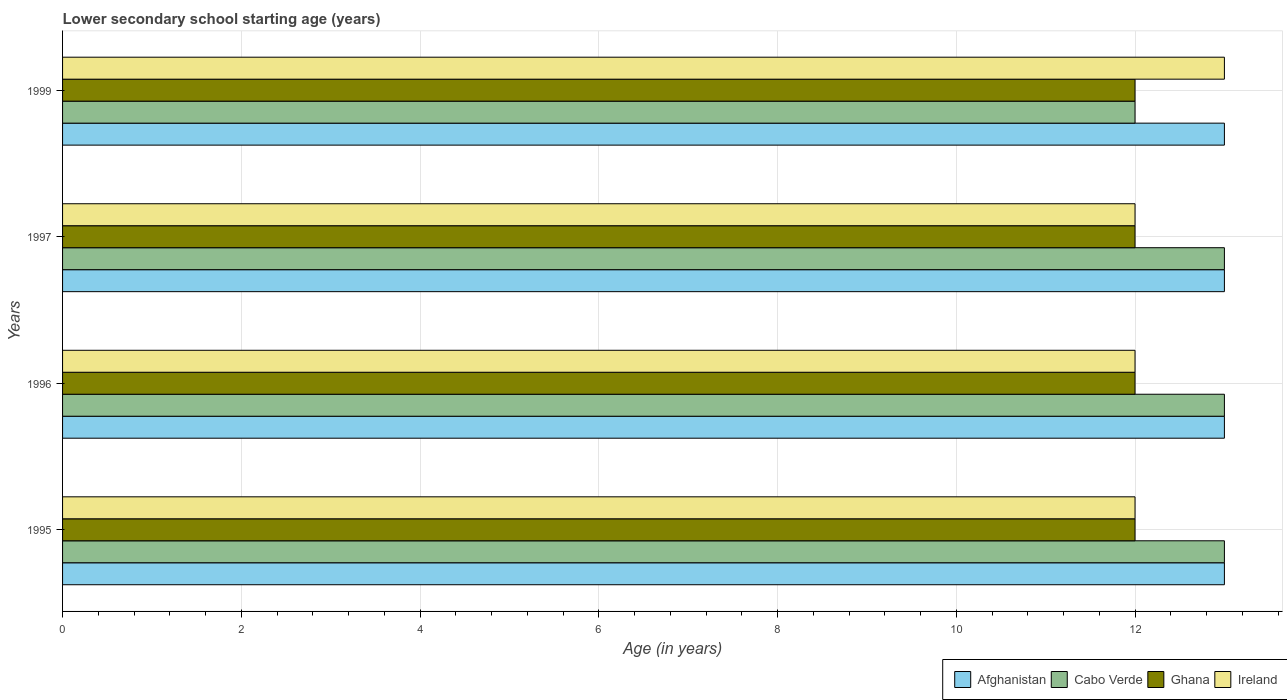How many groups of bars are there?
Your answer should be very brief. 4. Are the number of bars per tick equal to the number of legend labels?
Your response must be concise. Yes. Are the number of bars on each tick of the Y-axis equal?
Provide a succinct answer. Yes. How many bars are there on the 1st tick from the top?
Your response must be concise. 4. What is the label of the 4th group of bars from the top?
Make the answer very short. 1995. In how many cases, is the number of bars for a given year not equal to the number of legend labels?
Give a very brief answer. 0. What is the lower secondary school starting age of children in Ghana in 1997?
Your answer should be very brief. 12. Across all years, what is the maximum lower secondary school starting age of children in Cabo Verde?
Offer a very short reply. 13. Across all years, what is the minimum lower secondary school starting age of children in Ghana?
Provide a short and direct response. 12. In which year was the lower secondary school starting age of children in Cabo Verde maximum?
Provide a short and direct response. 1995. In which year was the lower secondary school starting age of children in Ireland minimum?
Keep it short and to the point. 1995. What is the difference between the lower secondary school starting age of children in Afghanistan in 1996 and that in 1999?
Give a very brief answer. 0. What is the average lower secondary school starting age of children in Cabo Verde per year?
Your answer should be compact. 12.75. In how many years, is the lower secondary school starting age of children in Cabo Verde greater than 1.2000000000000002 years?
Your answer should be very brief. 4. What is the ratio of the lower secondary school starting age of children in Ireland in 1995 to that in 1999?
Provide a succinct answer. 0.92. Is the lower secondary school starting age of children in Cabo Verde in 1997 less than that in 1999?
Offer a terse response. No. Is the difference between the lower secondary school starting age of children in Ireland in 1997 and 1999 greater than the difference between the lower secondary school starting age of children in Ghana in 1997 and 1999?
Provide a short and direct response. No. What is the difference between the highest and the second highest lower secondary school starting age of children in Ireland?
Ensure brevity in your answer.  1. What is the difference between the highest and the lowest lower secondary school starting age of children in Ghana?
Keep it short and to the point. 0. In how many years, is the lower secondary school starting age of children in Ireland greater than the average lower secondary school starting age of children in Ireland taken over all years?
Keep it short and to the point. 1. Is it the case that in every year, the sum of the lower secondary school starting age of children in Ghana and lower secondary school starting age of children in Cabo Verde is greater than the sum of lower secondary school starting age of children in Ireland and lower secondary school starting age of children in Afghanistan?
Your response must be concise. No. What does the 3rd bar from the top in 1995 represents?
Keep it short and to the point. Cabo Verde. What does the 1st bar from the bottom in 1997 represents?
Keep it short and to the point. Afghanistan. Is it the case that in every year, the sum of the lower secondary school starting age of children in Cabo Verde and lower secondary school starting age of children in Afghanistan is greater than the lower secondary school starting age of children in Ireland?
Your answer should be very brief. Yes. How many bars are there?
Keep it short and to the point. 16. Does the graph contain any zero values?
Provide a succinct answer. No. Does the graph contain grids?
Your response must be concise. Yes. How many legend labels are there?
Make the answer very short. 4. How are the legend labels stacked?
Offer a very short reply. Horizontal. What is the title of the graph?
Keep it short and to the point. Lower secondary school starting age (years). What is the label or title of the X-axis?
Provide a short and direct response. Age (in years). What is the Age (in years) of Afghanistan in 1995?
Offer a terse response. 13. What is the Age (in years) in Ireland in 1995?
Provide a succinct answer. 12. What is the Age (in years) of Afghanistan in 1996?
Keep it short and to the point. 13. What is the Age (in years) of Ghana in 1997?
Your answer should be very brief. 12. What is the Age (in years) in Cabo Verde in 1999?
Keep it short and to the point. 12. What is the Age (in years) in Ghana in 1999?
Provide a short and direct response. 12. Across all years, what is the maximum Age (in years) of Afghanistan?
Offer a very short reply. 13. Across all years, what is the maximum Age (in years) of Ghana?
Offer a very short reply. 12. Across all years, what is the minimum Age (in years) of Cabo Verde?
Give a very brief answer. 12. Across all years, what is the minimum Age (in years) of Ghana?
Ensure brevity in your answer.  12. Across all years, what is the minimum Age (in years) of Ireland?
Make the answer very short. 12. What is the total Age (in years) of Ghana in the graph?
Give a very brief answer. 48. What is the difference between the Age (in years) in Afghanistan in 1995 and that in 1996?
Offer a very short reply. 0. What is the difference between the Age (in years) of Ireland in 1995 and that in 1996?
Offer a terse response. 0. What is the difference between the Age (in years) in Afghanistan in 1995 and that in 1999?
Your answer should be compact. 0. What is the difference between the Age (in years) in Cabo Verde in 1995 and that in 1999?
Your answer should be compact. 1. What is the difference between the Age (in years) of Ghana in 1995 and that in 1999?
Your answer should be very brief. 0. What is the difference between the Age (in years) in Afghanistan in 1996 and that in 1997?
Make the answer very short. 0. What is the difference between the Age (in years) in Ghana in 1996 and that in 1997?
Ensure brevity in your answer.  0. What is the difference between the Age (in years) of Afghanistan in 1996 and that in 1999?
Your answer should be compact. 0. What is the difference between the Age (in years) in Ghana in 1996 and that in 1999?
Offer a terse response. 0. What is the difference between the Age (in years) of Ireland in 1996 and that in 1999?
Provide a short and direct response. -1. What is the difference between the Age (in years) in Cabo Verde in 1997 and that in 1999?
Give a very brief answer. 1. What is the difference between the Age (in years) in Ireland in 1997 and that in 1999?
Provide a succinct answer. -1. What is the difference between the Age (in years) of Afghanistan in 1995 and the Age (in years) of Cabo Verde in 1996?
Offer a terse response. 0. What is the difference between the Age (in years) in Afghanistan in 1995 and the Age (in years) in Ireland in 1996?
Offer a very short reply. 1. What is the difference between the Age (in years) of Cabo Verde in 1995 and the Age (in years) of Ghana in 1996?
Your answer should be very brief. 1. What is the difference between the Age (in years) of Afghanistan in 1995 and the Age (in years) of Cabo Verde in 1997?
Your answer should be very brief. 0. What is the difference between the Age (in years) of Cabo Verde in 1995 and the Age (in years) of Ireland in 1997?
Ensure brevity in your answer.  1. What is the difference between the Age (in years) of Ghana in 1995 and the Age (in years) of Ireland in 1997?
Keep it short and to the point. 0. What is the difference between the Age (in years) of Afghanistan in 1995 and the Age (in years) of Cabo Verde in 1999?
Your answer should be compact. 1. What is the difference between the Age (in years) of Afghanistan in 1995 and the Age (in years) of Ghana in 1999?
Give a very brief answer. 1. What is the difference between the Age (in years) of Afghanistan in 1996 and the Age (in years) of Ghana in 1997?
Your answer should be very brief. 1. What is the difference between the Age (in years) in Ghana in 1996 and the Age (in years) in Ireland in 1997?
Keep it short and to the point. 0. What is the difference between the Age (in years) in Afghanistan in 1996 and the Age (in years) in Cabo Verde in 1999?
Provide a succinct answer. 1. What is the difference between the Age (in years) of Ghana in 1996 and the Age (in years) of Ireland in 1999?
Give a very brief answer. -1. What is the difference between the Age (in years) of Afghanistan in 1997 and the Age (in years) of Cabo Verde in 1999?
Offer a very short reply. 1. What is the difference between the Age (in years) of Cabo Verde in 1997 and the Age (in years) of Ghana in 1999?
Your answer should be compact. 1. What is the difference between the Age (in years) of Ghana in 1997 and the Age (in years) of Ireland in 1999?
Your answer should be compact. -1. What is the average Age (in years) of Afghanistan per year?
Your response must be concise. 13. What is the average Age (in years) of Cabo Verde per year?
Offer a terse response. 12.75. What is the average Age (in years) of Ireland per year?
Offer a very short reply. 12.25. In the year 1995, what is the difference between the Age (in years) in Afghanistan and Age (in years) in Cabo Verde?
Your answer should be compact. 0. In the year 1995, what is the difference between the Age (in years) in Afghanistan and Age (in years) in Ghana?
Offer a very short reply. 1. In the year 1996, what is the difference between the Age (in years) in Afghanistan and Age (in years) in Ghana?
Your response must be concise. 1. In the year 1996, what is the difference between the Age (in years) in Afghanistan and Age (in years) in Ireland?
Provide a succinct answer. 1. In the year 1996, what is the difference between the Age (in years) in Cabo Verde and Age (in years) in Ireland?
Make the answer very short. 1. In the year 1996, what is the difference between the Age (in years) of Ghana and Age (in years) of Ireland?
Offer a very short reply. 0. In the year 1997, what is the difference between the Age (in years) of Afghanistan and Age (in years) of Ghana?
Your response must be concise. 1. In the year 1997, what is the difference between the Age (in years) in Cabo Verde and Age (in years) in Ireland?
Offer a terse response. 1. In the year 1997, what is the difference between the Age (in years) of Ghana and Age (in years) of Ireland?
Your answer should be very brief. 0. In the year 1999, what is the difference between the Age (in years) of Afghanistan and Age (in years) of Cabo Verde?
Ensure brevity in your answer.  1. In the year 1999, what is the difference between the Age (in years) in Afghanistan and Age (in years) in Ghana?
Keep it short and to the point. 1. In the year 1999, what is the difference between the Age (in years) in Cabo Verde and Age (in years) in Ghana?
Ensure brevity in your answer.  0. In the year 1999, what is the difference between the Age (in years) in Cabo Verde and Age (in years) in Ireland?
Provide a short and direct response. -1. In the year 1999, what is the difference between the Age (in years) of Ghana and Age (in years) of Ireland?
Your answer should be very brief. -1. What is the ratio of the Age (in years) of Cabo Verde in 1995 to that in 1996?
Make the answer very short. 1. What is the ratio of the Age (in years) of Ireland in 1995 to that in 1996?
Your answer should be compact. 1. What is the ratio of the Age (in years) of Afghanistan in 1995 to that in 1997?
Your answer should be very brief. 1. What is the ratio of the Age (in years) in Cabo Verde in 1995 to that in 1997?
Ensure brevity in your answer.  1. What is the ratio of the Age (in years) in Ireland in 1995 to that in 1997?
Keep it short and to the point. 1. What is the ratio of the Age (in years) in Afghanistan in 1995 to that in 1999?
Keep it short and to the point. 1. What is the ratio of the Age (in years) in Ireland in 1995 to that in 1999?
Offer a very short reply. 0.92. What is the ratio of the Age (in years) of Afghanistan in 1996 to that in 1997?
Offer a terse response. 1. What is the ratio of the Age (in years) in Ireland in 1996 to that in 1997?
Provide a short and direct response. 1. What is the ratio of the Age (in years) of Cabo Verde in 1997 to that in 1999?
Your answer should be very brief. 1.08. What is the ratio of the Age (in years) in Ghana in 1997 to that in 1999?
Offer a terse response. 1. What is the difference between the highest and the second highest Age (in years) in Cabo Verde?
Offer a terse response. 0. What is the difference between the highest and the lowest Age (in years) of Cabo Verde?
Provide a short and direct response. 1. What is the difference between the highest and the lowest Age (in years) in Ireland?
Ensure brevity in your answer.  1. 